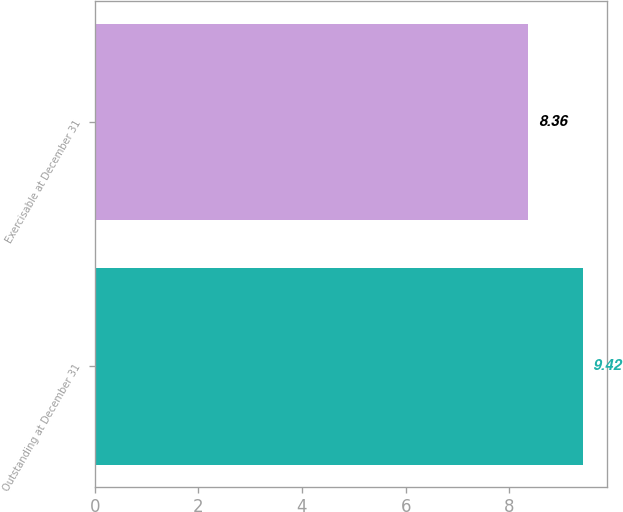Convert chart to OTSL. <chart><loc_0><loc_0><loc_500><loc_500><bar_chart><fcel>Outstanding at December 31<fcel>Exercisable at December 31<nl><fcel>9.42<fcel>8.36<nl></chart> 